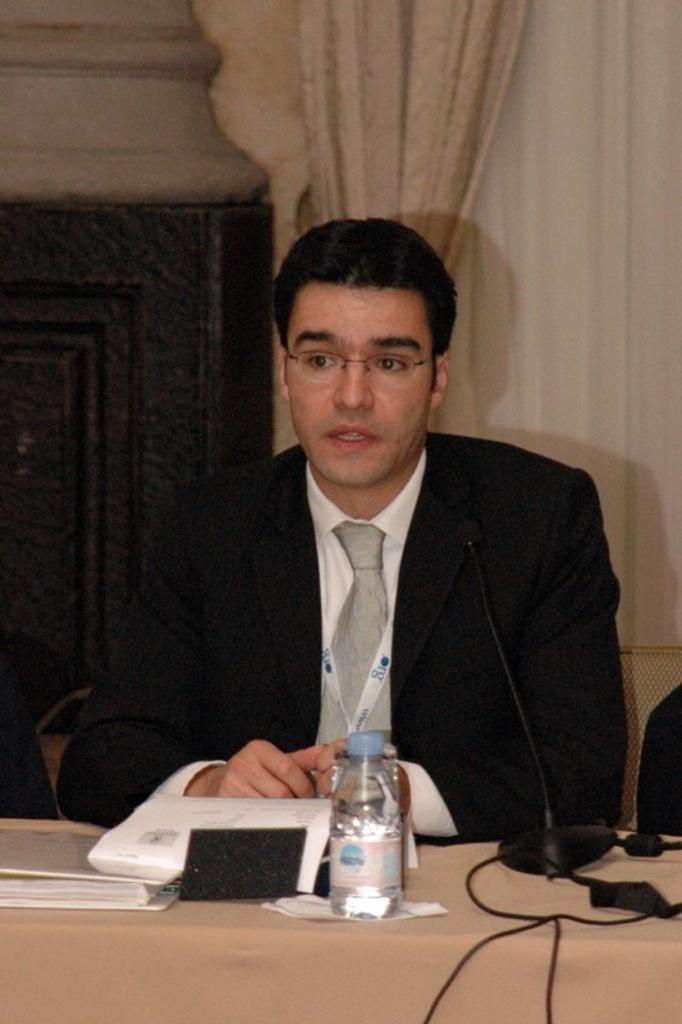Who is the main subject in the image? There is a person in the image. What is the person wearing? The person is wearing a suit. What is the person doing in the image? The person is sitting and speaking in front of a mic. What is in front of the person? There is a table in front of the person. What can be seen on the table? There are objects on the table. What type of discussion is taking place between the snakes in the image? There are no snakes present in the image; it features a person sitting and speaking in front of a mic. What advice might the dad give to the person in the image? There is no dad present in the image, so it is not possible to determine what advice he might give. 